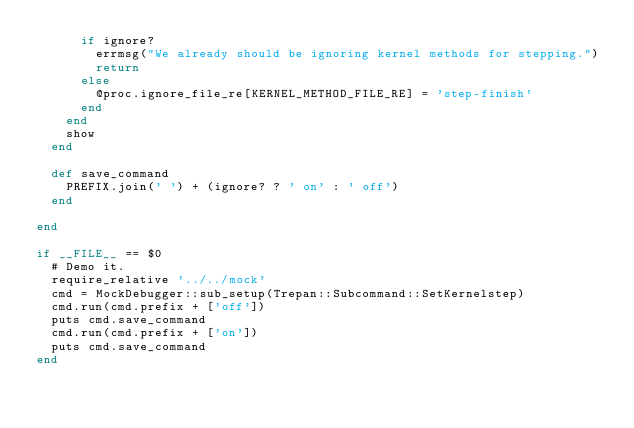<code> <loc_0><loc_0><loc_500><loc_500><_Ruby_>      if ignore?
        errmsg("We already should be ignoring kernel methods for stepping.")
        return
      else
        @proc.ignore_file_re[KERNEL_METHOD_FILE_RE] = 'step-finish'
      end
    end
    show
  end

  def save_command
    PREFIX.join(' ') + (ignore? ? ' on' : ' off')
  end

end

if __FILE__ == $0
  # Demo it.
  require_relative '../../mock'
  cmd = MockDebugger::sub_setup(Trepan::Subcommand::SetKernelstep)
  cmd.run(cmd.prefix + ['off'])
  puts cmd.save_command
  cmd.run(cmd.prefix + ['on'])
  puts cmd.save_command
end
</code> 